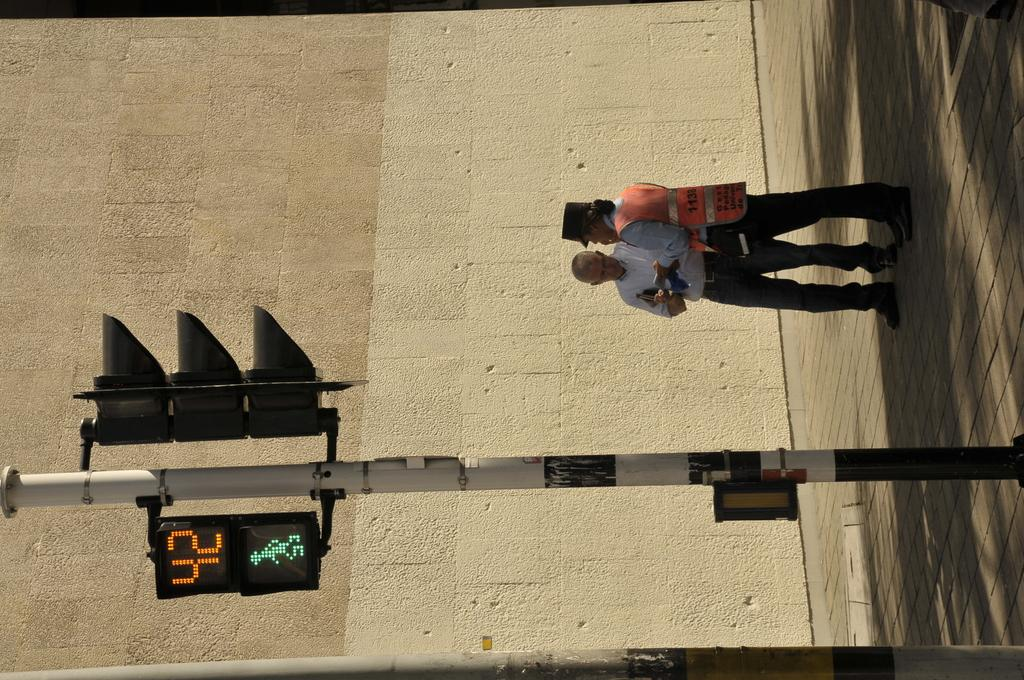<image>
Relay a brief, clear account of the picture shown. Two people have 42 seconds left to walk across the street. 